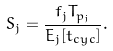<formula> <loc_0><loc_0><loc_500><loc_500>S _ { j } = \frac { f _ { j } T _ { p _ { j } } } { E _ { j } [ t _ { c y c } ] } .</formula> 